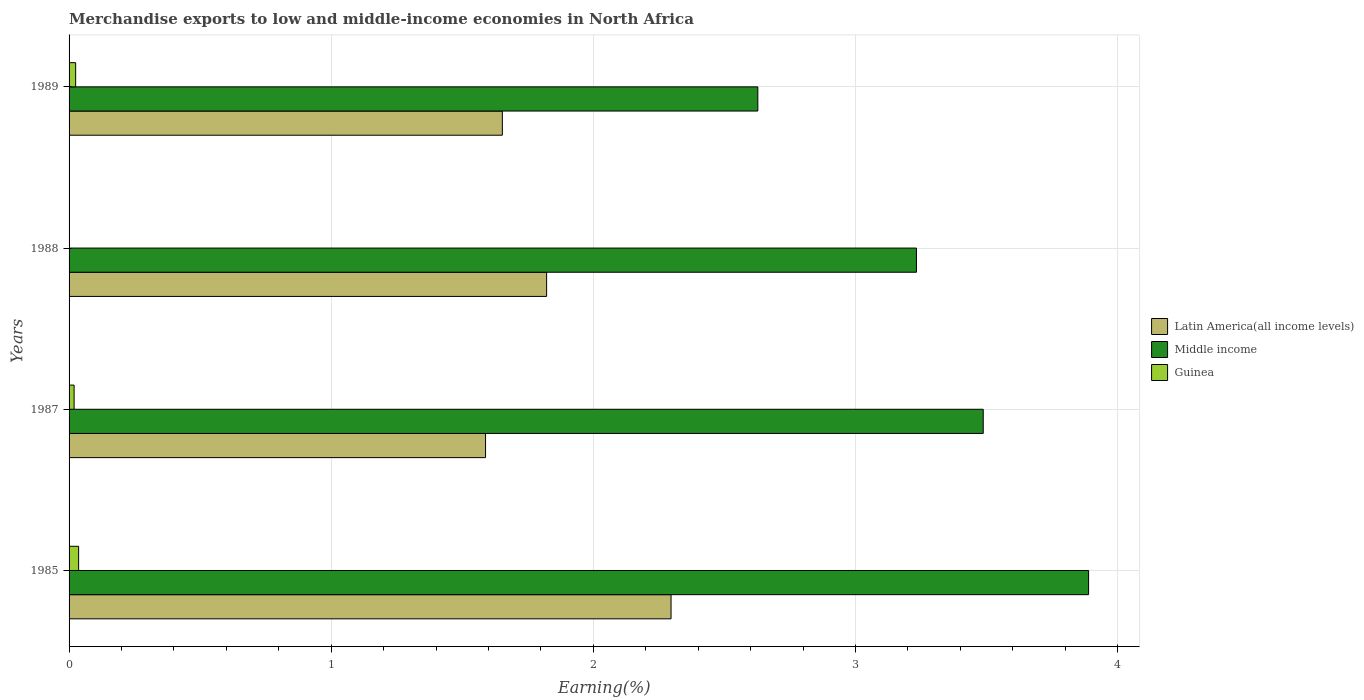How many different coloured bars are there?
Offer a terse response. 3. Are the number of bars per tick equal to the number of legend labels?
Give a very brief answer. Yes. How many bars are there on the 1st tick from the bottom?
Your answer should be compact. 3. In how many cases, is the number of bars for a given year not equal to the number of legend labels?
Your answer should be very brief. 0. What is the percentage of amount earned from merchandise exports in Middle income in 1989?
Your answer should be compact. 2.63. Across all years, what is the maximum percentage of amount earned from merchandise exports in Middle income?
Your answer should be compact. 3.89. Across all years, what is the minimum percentage of amount earned from merchandise exports in Guinea?
Offer a very short reply. 0. In which year was the percentage of amount earned from merchandise exports in Middle income minimum?
Keep it short and to the point. 1989. What is the total percentage of amount earned from merchandise exports in Guinea in the graph?
Provide a short and direct response. 0.08. What is the difference between the percentage of amount earned from merchandise exports in Guinea in 1988 and that in 1989?
Your answer should be compact. -0.02. What is the difference between the percentage of amount earned from merchandise exports in Latin America(all income levels) in 1988 and the percentage of amount earned from merchandise exports in Middle income in 1985?
Ensure brevity in your answer.  -2.07. What is the average percentage of amount earned from merchandise exports in Middle income per year?
Ensure brevity in your answer.  3.31. In the year 1985, what is the difference between the percentage of amount earned from merchandise exports in Guinea and percentage of amount earned from merchandise exports in Middle income?
Your response must be concise. -3.85. In how many years, is the percentage of amount earned from merchandise exports in Guinea greater than 3.4 %?
Your answer should be compact. 0. What is the ratio of the percentage of amount earned from merchandise exports in Middle income in 1985 to that in 1988?
Provide a short and direct response. 1.2. What is the difference between the highest and the second highest percentage of amount earned from merchandise exports in Latin America(all income levels)?
Your answer should be compact. 0.47. What is the difference between the highest and the lowest percentage of amount earned from merchandise exports in Guinea?
Provide a short and direct response. 0.04. In how many years, is the percentage of amount earned from merchandise exports in Middle income greater than the average percentage of amount earned from merchandise exports in Middle income taken over all years?
Your answer should be compact. 2. What does the 3rd bar from the top in 1985 represents?
Keep it short and to the point. Latin America(all income levels). What does the 1st bar from the bottom in 1989 represents?
Keep it short and to the point. Latin America(all income levels). How many years are there in the graph?
Keep it short and to the point. 4. Are the values on the major ticks of X-axis written in scientific E-notation?
Give a very brief answer. No. What is the title of the graph?
Provide a short and direct response. Merchandise exports to low and middle-income economies in North Africa. Does "OECD members" appear as one of the legend labels in the graph?
Your answer should be compact. No. What is the label or title of the X-axis?
Offer a terse response. Earning(%). What is the label or title of the Y-axis?
Give a very brief answer. Years. What is the Earning(%) of Latin America(all income levels) in 1985?
Your answer should be compact. 2.3. What is the Earning(%) in Middle income in 1985?
Your answer should be very brief. 3.89. What is the Earning(%) of Guinea in 1985?
Offer a terse response. 0.04. What is the Earning(%) in Latin America(all income levels) in 1987?
Your answer should be very brief. 1.59. What is the Earning(%) in Middle income in 1987?
Your answer should be very brief. 3.49. What is the Earning(%) of Guinea in 1987?
Offer a very short reply. 0.02. What is the Earning(%) of Latin America(all income levels) in 1988?
Give a very brief answer. 1.82. What is the Earning(%) in Middle income in 1988?
Provide a short and direct response. 3.23. What is the Earning(%) in Guinea in 1988?
Offer a terse response. 0. What is the Earning(%) in Latin America(all income levels) in 1989?
Provide a succinct answer. 1.65. What is the Earning(%) of Middle income in 1989?
Offer a very short reply. 2.63. What is the Earning(%) of Guinea in 1989?
Offer a very short reply. 0.03. Across all years, what is the maximum Earning(%) in Latin America(all income levels)?
Your answer should be very brief. 2.3. Across all years, what is the maximum Earning(%) of Middle income?
Offer a very short reply. 3.89. Across all years, what is the maximum Earning(%) in Guinea?
Give a very brief answer. 0.04. Across all years, what is the minimum Earning(%) in Latin America(all income levels)?
Provide a short and direct response. 1.59. Across all years, what is the minimum Earning(%) of Middle income?
Offer a terse response. 2.63. Across all years, what is the minimum Earning(%) of Guinea?
Your answer should be compact. 0. What is the total Earning(%) in Latin America(all income levels) in the graph?
Your response must be concise. 7.36. What is the total Earning(%) of Middle income in the graph?
Keep it short and to the point. 13.24. What is the total Earning(%) in Guinea in the graph?
Give a very brief answer. 0.08. What is the difference between the Earning(%) of Latin America(all income levels) in 1985 and that in 1987?
Offer a very short reply. 0.71. What is the difference between the Earning(%) in Middle income in 1985 and that in 1987?
Your answer should be compact. 0.4. What is the difference between the Earning(%) in Guinea in 1985 and that in 1987?
Your answer should be compact. 0.02. What is the difference between the Earning(%) of Latin America(all income levels) in 1985 and that in 1988?
Provide a short and direct response. 0.47. What is the difference between the Earning(%) in Middle income in 1985 and that in 1988?
Your response must be concise. 0.66. What is the difference between the Earning(%) in Guinea in 1985 and that in 1988?
Your answer should be compact. 0.04. What is the difference between the Earning(%) of Latin America(all income levels) in 1985 and that in 1989?
Your answer should be very brief. 0.64. What is the difference between the Earning(%) of Middle income in 1985 and that in 1989?
Your answer should be very brief. 1.26. What is the difference between the Earning(%) in Guinea in 1985 and that in 1989?
Ensure brevity in your answer.  0.01. What is the difference between the Earning(%) in Latin America(all income levels) in 1987 and that in 1988?
Make the answer very short. -0.23. What is the difference between the Earning(%) of Middle income in 1987 and that in 1988?
Make the answer very short. 0.25. What is the difference between the Earning(%) of Guinea in 1987 and that in 1988?
Your answer should be very brief. 0.02. What is the difference between the Earning(%) of Latin America(all income levels) in 1987 and that in 1989?
Keep it short and to the point. -0.06. What is the difference between the Earning(%) in Middle income in 1987 and that in 1989?
Give a very brief answer. 0.86. What is the difference between the Earning(%) in Guinea in 1987 and that in 1989?
Your answer should be very brief. -0.01. What is the difference between the Earning(%) in Latin America(all income levels) in 1988 and that in 1989?
Provide a short and direct response. 0.17. What is the difference between the Earning(%) in Middle income in 1988 and that in 1989?
Provide a short and direct response. 0.61. What is the difference between the Earning(%) in Guinea in 1988 and that in 1989?
Provide a short and direct response. -0.02. What is the difference between the Earning(%) in Latin America(all income levels) in 1985 and the Earning(%) in Middle income in 1987?
Give a very brief answer. -1.19. What is the difference between the Earning(%) of Latin America(all income levels) in 1985 and the Earning(%) of Guinea in 1987?
Provide a short and direct response. 2.28. What is the difference between the Earning(%) of Middle income in 1985 and the Earning(%) of Guinea in 1987?
Provide a short and direct response. 3.87. What is the difference between the Earning(%) of Latin America(all income levels) in 1985 and the Earning(%) of Middle income in 1988?
Keep it short and to the point. -0.94. What is the difference between the Earning(%) in Latin America(all income levels) in 1985 and the Earning(%) in Guinea in 1988?
Provide a succinct answer. 2.3. What is the difference between the Earning(%) of Middle income in 1985 and the Earning(%) of Guinea in 1988?
Make the answer very short. 3.89. What is the difference between the Earning(%) in Latin America(all income levels) in 1985 and the Earning(%) in Middle income in 1989?
Offer a terse response. -0.33. What is the difference between the Earning(%) of Latin America(all income levels) in 1985 and the Earning(%) of Guinea in 1989?
Your response must be concise. 2.27. What is the difference between the Earning(%) in Middle income in 1985 and the Earning(%) in Guinea in 1989?
Your answer should be very brief. 3.86. What is the difference between the Earning(%) in Latin America(all income levels) in 1987 and the Earning(%) in Middle income in 1988?
Provide a short and direct response. -1.64. What is the difference between the Earning(%) of Latin America(all income levels) in 1987 and the Earning(%) of Guinea in 1988?
Make the answer very short. 1.59. What is the difference between the Earning(%) in Middle income in 1987 and the Earning(%) in Guinea in 1988?
Your answer should be very brief. 3.49. What is the difference between the Earning(%) in Latin America(all income levels) in 1987 and the Earning(%) in Middle income in 1989?
Provide a succinct answer. -1.04. What is the difference between the Earning(%) in Latin America(all income levels) in 1987 and the Earning(%) in Guinea in 1989?
Provide a succinct answer. 1.56. What is the difference between the Earning(%) in Middle income in 1987 and the Earning(%) in Guinea in 1989?
Your response must be concise. 3.46. What is the difference between the Earning(%) in Latin America(all income levels) in 1988 and the Earning(%) in Middle income in 1989?
Keep it short and to the point. -0.81. What is the difference between the Earning(%) of Latin America(all income levels) in 1988 and the Earning(%) of Guinea in 1989?
Give a very brief answer. 1.8. What is the difference between the Earning(%) in Middle income in 1988 and the Earning(%) in Guinea in 1989?
Provide a succinct answer. 3.21. What is the average Earning(%) in Latin America(all income levels) per year?
Offer a very short reply. 1.84. What is the average Earning(%) of Middle income per year?
Ensure brevity in your answer.  3.31. What is the average Earning(%) of Guinea per year?
Offer a very short reply. 0.02. In the year 1985, what is the difference between the Earning(%) of Latin America(all income levels) and Earning(%) of Middle income?
Your answer should be very brief. -1.59. In the year 1985, what is the difference between the Earning(%) in Latin America(all income levels) and Earning(%) in Guinea?
Provide a short and direct response. 2.26. In the year 1985, what is the difference between the Earning(%) of Middle income and Earning(%) of Guinea?
Make the answer very short. 3.85. In the year 1987, what is the difference between the Earning(%) of Latin America(all income levels) and Earning(%) of Middle income?
Provide a short and direct response. -1.9. In the year 1987, what is the difference between the Earning(%) in Latin America(all income levels) and Earning(%) in Guinea?
Your response must be concise. 1.57. In the year 1987, what is the difference between the Earning(%) in Middle income and Earning(%) in Guinea?
Make the answer very short. 3.47. In the year 1988, what is the difference between the Earning(%) of Latin America(all income levels) and Earning(%) of Middle income?
Keep it short and to the point. -1.41. In the year 1988, what is the difference between the Earning(%) of Latin America(all income levels) and Earning(%) of Guinea?
Your answer should be very brief. 1.82. In the year 1988, what is the difference between the Earning(%) in Middle income and Earning(%) in Guinea?
Offer a terse response. 3.23. In the year 1989, what is the difference between the Earning(%) in Latin America(all income levels) and Earning(%) in Middle income?
Your response must be concise. -0.97. In the year 1989, what is the difference between the Earning(%) of Latin America(all income levels) and Earning(%) of Guinea?
Provide a succinct answer. 1.63. In the year 1989, what is the difference between the Earning(%) in Middle income and Earning(%) in Guinea?
Keep it short and to the point. 2.6. What is the ratio of the Earning(%) in Latin America(all income levels) in 1985 to that in 1987?
Offer a terse response. 1.45. What is the ratio of the Earning(%) in Middle income in 1985 to that in 1987?
Your response must be concise. 1.12. What is the ratio of the Earning(%) of Guinea in 1985 to that in 1987?
Offer a terse response. 1.9. What is the ratio of the Earning(%) in Latin America(all income levels) in 1985 to that in 1988?
Give a very brief answer. 1.26. What is the ratio of the Earning(%) of Middle income in 1985 to that in 1988?
Give a very brief answer. 1.2. What is the ratio of the Earning(%) of Guinea in 1985 to that in 1988?
Keep it short and to the point. 187.1. What is the ratio of the Earning(%) in Latin America(all income levels) in 1985 to that in 1989?
Offer a very short reply. 1.39. What is the ratio of the Earning(%) in Middle income in 1985 to that in 1989?
Provide a short and direct response. 1.48. What is the ratio of the Earning(%) in Guinea in 1985 to that in 1989?
Keep it short and to the point. 1.45. What is the ratio of the Earning(%) of Latin America(all income levels) in 1987 to that in 1988?
Make the answer very short. 0.87. What is the ratio of the Earning(%) in Middle income in 1987 to that in 1988?
Your response must be concise. 1.08. What is the ratio of the Earning(%) in Guinea in 1987 to that in 1988?
Ensure brevity in your answer.  98.59. What is the ratio of the Earning(%) in Latin America(all income levels) in 1987 to that in 1989?
Offer a very short reply. 0.96. What is the ratio of the Earning(%) of Middle income in 1987 to that in 1989?
Ensure brevity in your answer.  1.33. What is the ratio of the Earning(%) in Guinea in 1987 to that in 1989?
Offer a very short reply. 0.76. What is the ratio of the Earning(%) of Latin America(all income levels) in 1988 to that in 1989?
Your answer should be compact. 1.1. What is the ratio of the Earning(%) in Middle income in 1988 to that in 1989?
Provide a succinct answer. 1.23. What is the ratio of the Earning(%) in Guinea in 1988 to that in 1989?
Make the answer very short. 0.01. What is the difference between the highest and the second highest Earning(%) in Latin America(all income levels)?
Provide a succinct answer. 0.47. What is the difference between the highest and the second highest Earning(%) of Middle income?
Keep it short and to the point. 0.4. What is the difference between the highest and the second highest Earning(%) in Guinea?
Ensure brevity in your answer.  0.01. What is the difference between the highest and the lowest Earning(%) of Latin America(all income levels)?
Make the answer very short. 0.71. What is the difference between the highest and the lowest Earning(%) in Middle income?
Keep it short and to the point. 1.26. What is the difference between the highest and the lowest Earning(%) in Guinea?
Provide a succinct answer. 0.04. 